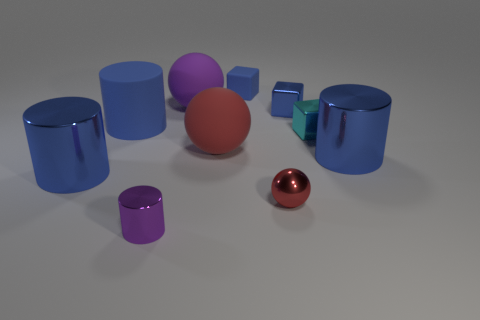Is the rubber cube the same color as the big rubber cylinder?
Offer a very short reply. Yes. There is a cyan metal block that is behind the blue object that is to the right of the small cyan shiny block; what size is it?
Offer a terse response. Small. What number of objects are red balls that are to the right of the large red matte ball or tiny blue cubes in front of the large purple object?
Give a very brief answer. 2. Are there fewer small cyan objects than balls?
Make the answer very short. Yes. What number of things are big red matte objects or large things?
Offer a very short reply. 5. Is the small cyan object the same shape as the small matte object?
Make the answer very short. Yes. There is a metallic cylinder to the right of the purple metal cylinder; is it the same size as the blue shiny object to the left of the small blue rubber object?
Give a very brief answer. Yes. There is a big thing that is both behind the cyan metal thing and on the right side of the tiny shiny cylinder; what material is it?
Your answer should be very brief. Rubber. Is there any other thing of the same color as the matte cube?
Provide a succinct answer. Yes. Is the number of big purple balls that are in front of the cyan metal block less than the number of cyan metal cubes?
Make the answer very short. Yes. 